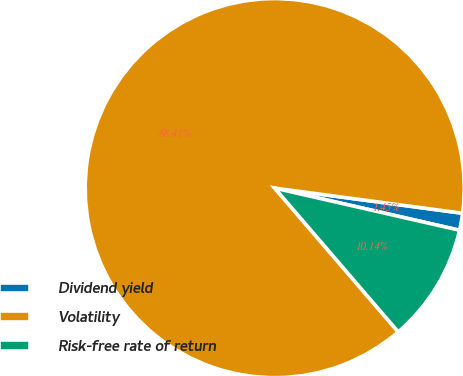Convert chart. <chart><loc_0><loc_0><loc_500><loc_500><pie_chart><fcel>Dividend yield<fcel>Volatility<fcel>Risk-free rate of return<nl><fcel>1.45%<fcel>88.41%<fcel>10.14%<nl></chart> 